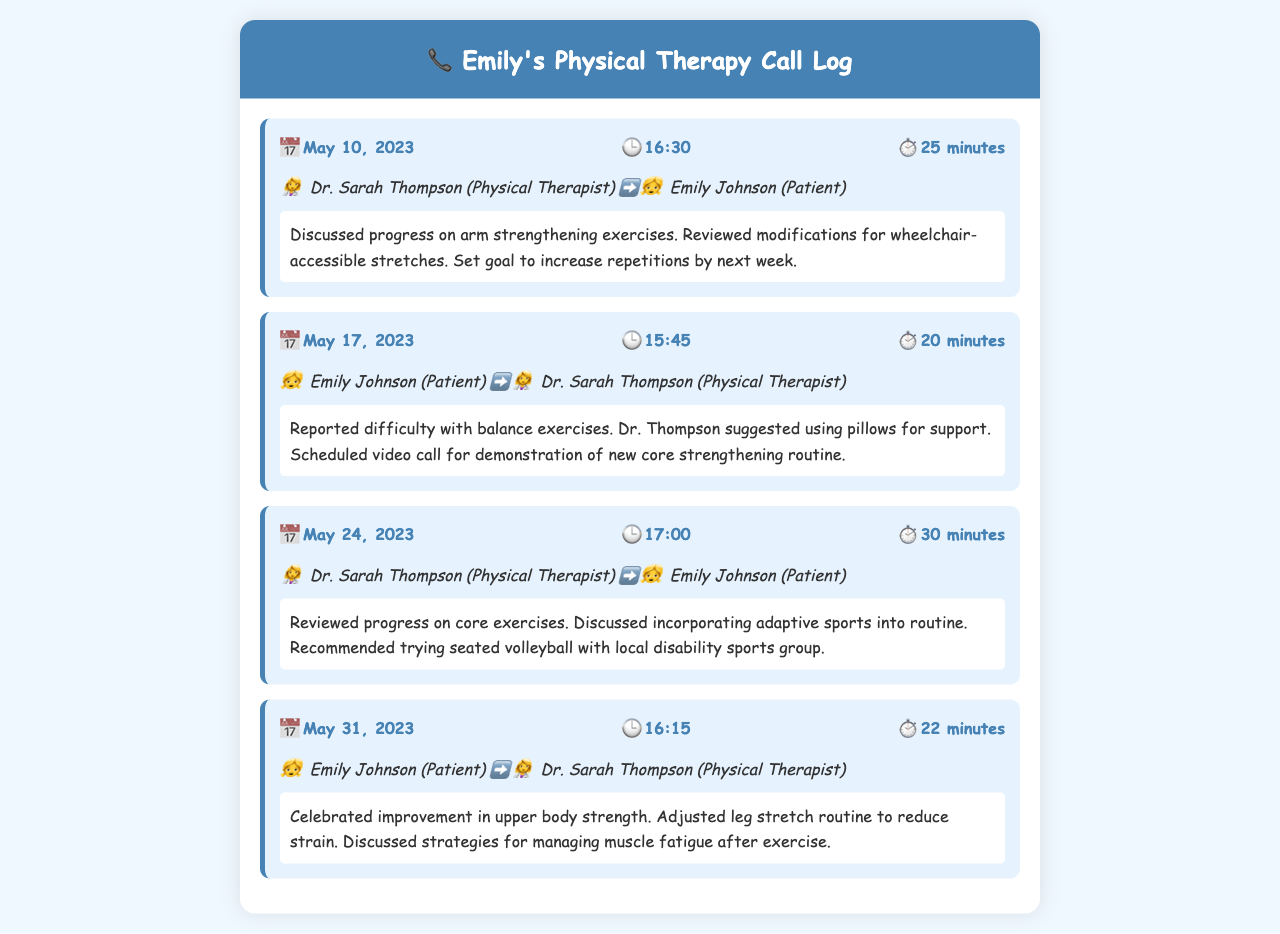What date was the first call? The first call entry is on May 10, 2023.
Answer: May 10, 2023 How long was the call on May 31, 2023? The call duration is specifically mentioned for May 31, 2023, which is 22 minutes.
Answer: 22 minutes Who is Emily's physical therapist? The document states the therapist's name is Dr. Sarah Thompson.
Answer: Dr. Sarah Thompson What was discussed during the call on May 24, 2023? The summary mentions progress on core exercises and introducing adaptive sports.
Answer: Core exercises and adaptive sports What exercise modification was suggested for balance exercises? The therapist suggested using pillows for support during balance exercises.
Answer: Pillows for support How many calls took place in May 2023? There are four call entries recorded in May 2023.
Answer: Four What was Emily's goal by the next week following the first call? The goal set was to increase repetitions by the next week.
Answer: Increase repetitions What new activity was recommended to Emily? The therapist recommended trying seated volleyball with a local disability sports group.
Answer: Seated volleyball 